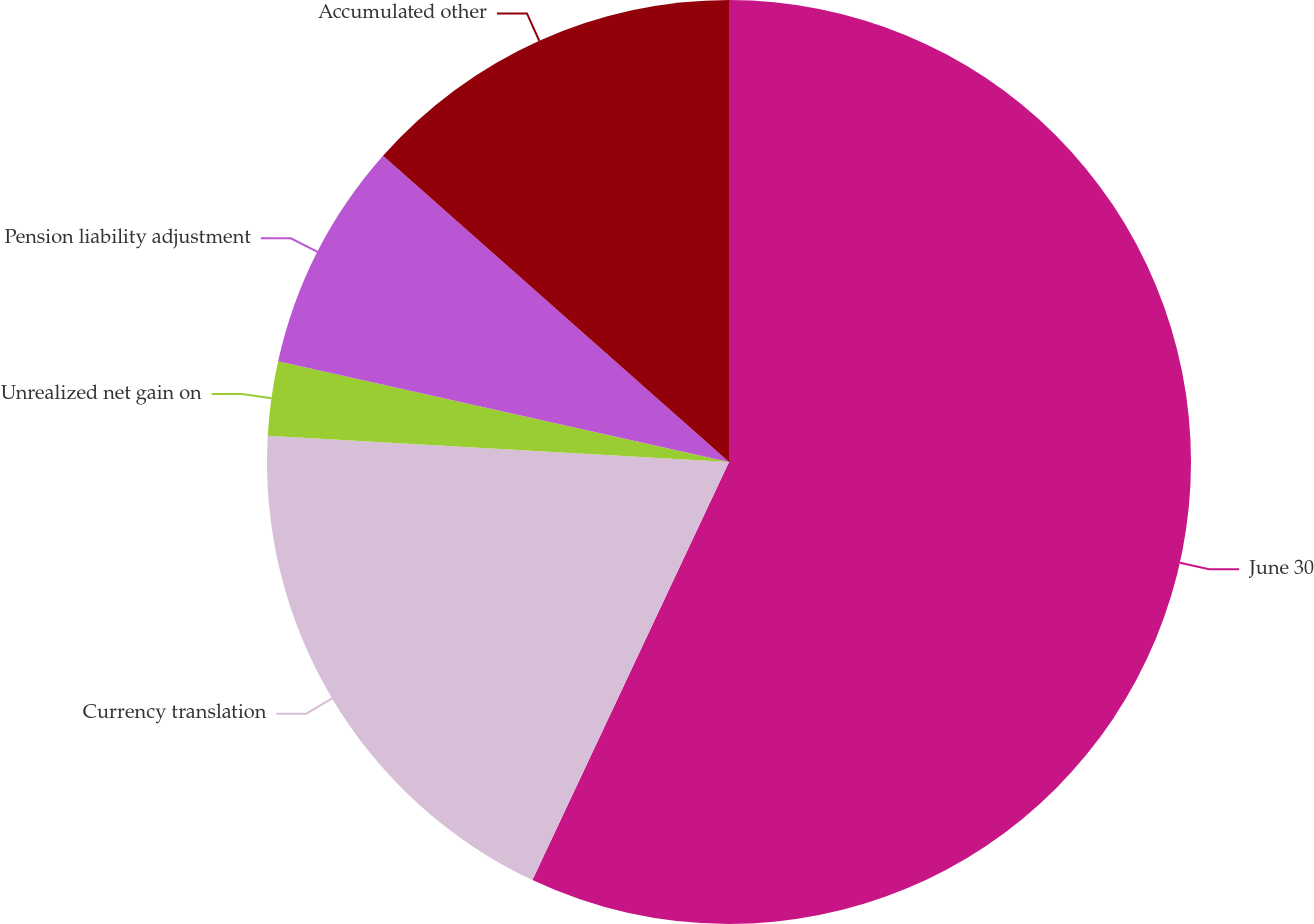Convert chart to OTSL. <chart><loc_0><loc_0><loc_500><loc_500><pie_chart><fcel>June 30<fcel>Currency translation<fcel>Unrealized net gain on<fcel>Pension liability adjustment<fcel>Accumulated other<nl><fcel>56.99%<fcel>18.91%<fcel>2.59%<fcel>8.03%<fcel>13.47%<nl></chart> 